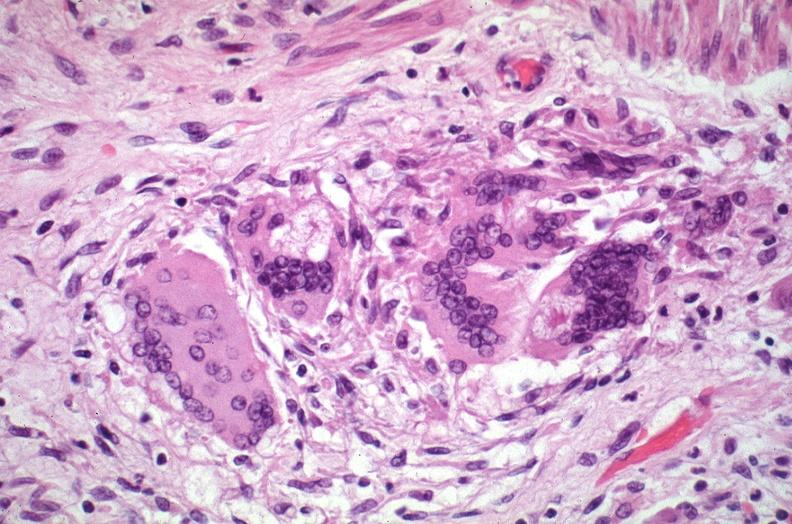where is this?
Answer the question using a single word or phrase. Lung 